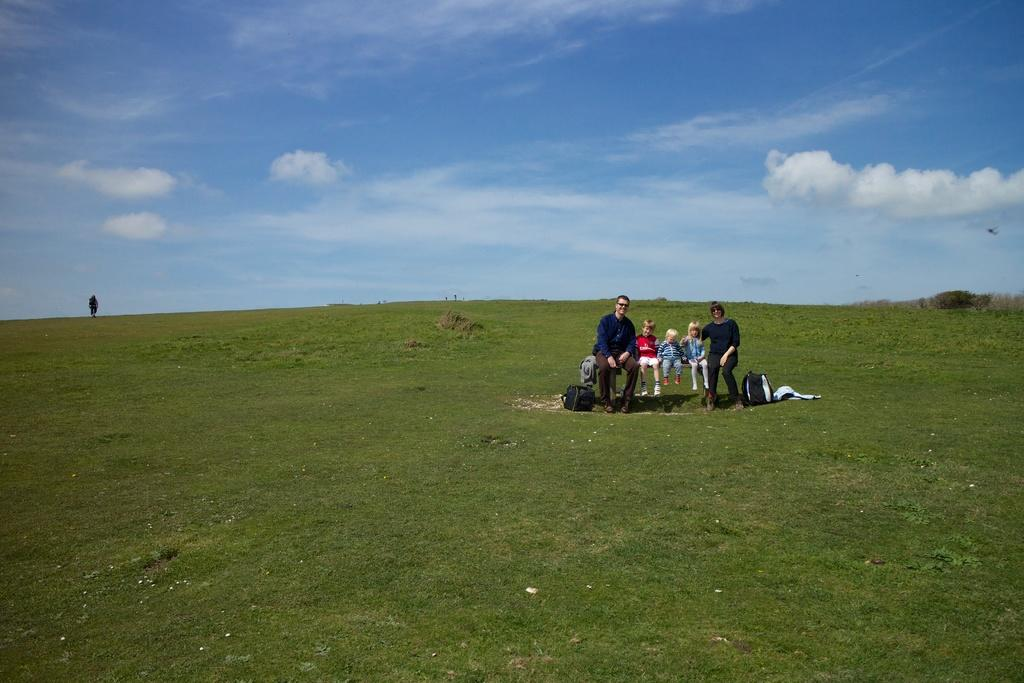How many people are sitting on the bench in the image? There are five persons sitting on a bench in the image. What can be seen on the right side of the image? There are trees on the right side of the image. What type of ground is visible behind the people? There is grass visible behind the people. What is visible in the background of the image? The sky is visible in the background of the image. What color is the spring in the image? There is no spring present in the image, and the concept of a "color" for a season does not apply. 